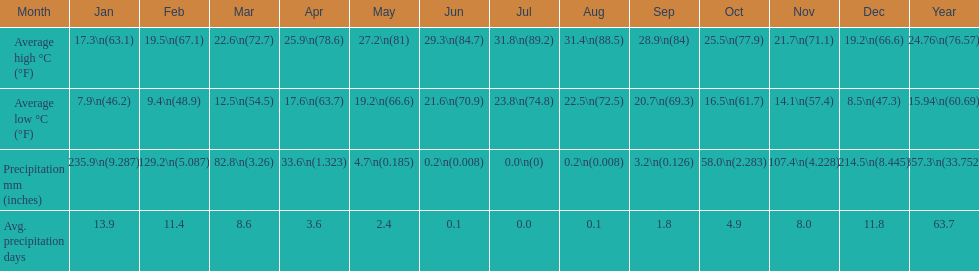Which country is haifa in? Israel. 